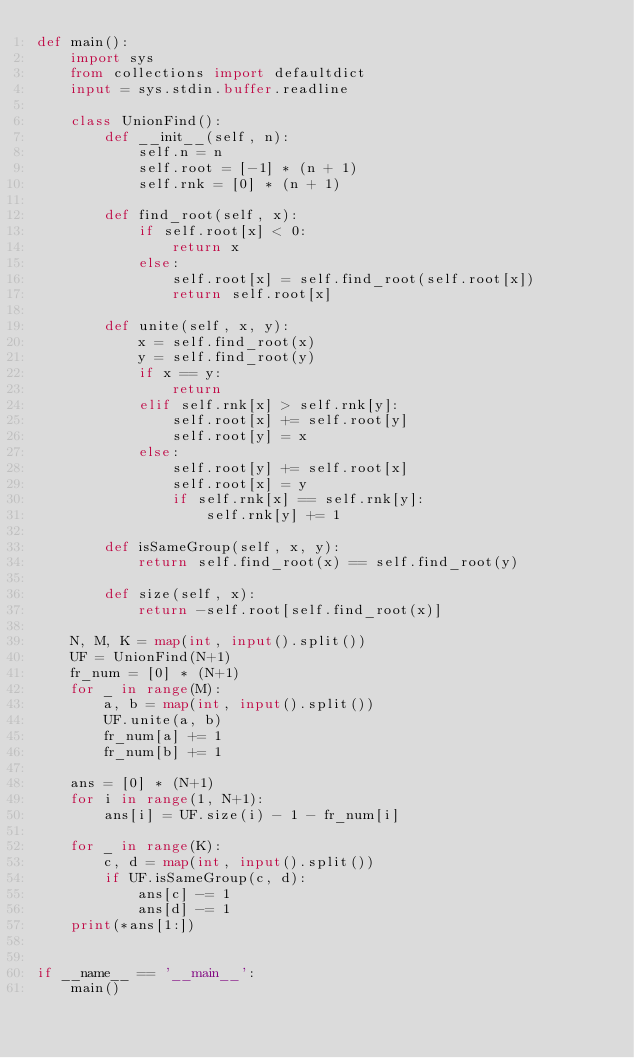Convert code to text. <code><loc_0><loc_0><loc_500><loc_500><_Python_>def main():
    import sys
    from collections import defaultdict
    input = sys.stdin.buffer.readline

    class UnionFind():
        def __init__(self, n):
            self.n = n
            self.root = [-1] * (n + 1)
            self.rnk = [0] * (n + 1)

        def find_root(self, x):
            if self.root[x] < 0:
                return x
            else:
                self.root[x] = self.find_root(self.root[x])
                return self.root[x]

        def unite(self, x, y):
            x = self.find_root(x)
            y = self.find_root(y)
            if x == y:
                return
            elif self.rnk[x] > self.rnk[y]:
                self.root[x] += self.root[y]
                self.root[y] = x
            else:
                self.root[y] += self.root[x]
                self.root[x] = y
                if self.rnk[x] == self.rnk[y]:
                    self.rnk[y] += 1

        def isSameGroup(self, x, y):
            return self.find_root(x) == self.find_root(y)

        def size(self, x):
            return -self.root[self.find_root(x)]

    N, M, K = map(int, input().split())
    UF = UnionFind(N+1)
    fr_num = [0] * (N+1)
    for _ in range(M):
        a, b = map(int, input().split())
        UF.unite(a, b)
        fr_num[a] += 1
        fr_num[b] += 1

    ans = [0] * (N+1)
    for i in range(1, N+1):
        ans[i] = UF.size(i) - 1 - fr_num[i]

    for _ in range(K):
        c, d = map(int, input().split())
        if UF.isSameGroup(c, d):
            ans[c] -= 1
            ans[d] -= 1
    print(*ans[1:])


if __name__ == '__main__':
    main()
</code> 